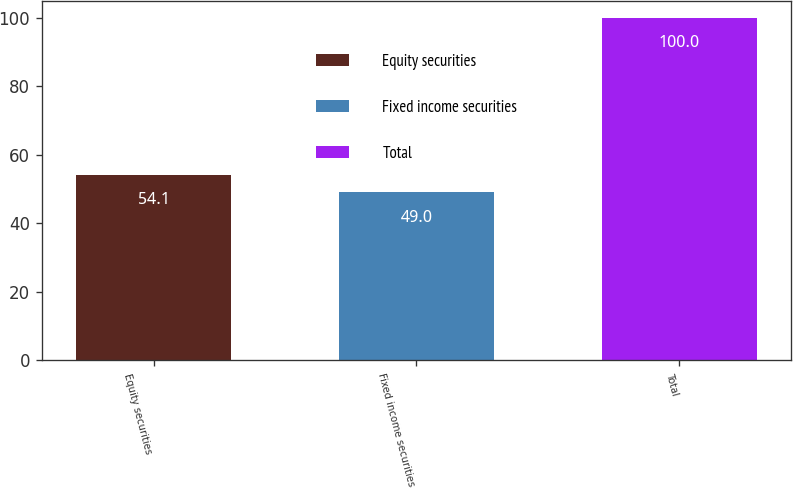<chart> <loc_0><loc_0><loc_500><loc_500><bar_chart><fcel>Equity securities<fcel>Fixed income securities<fcel>Total<nl><fcel>54.1<fcel>49<fcel>100<nl></chart> 